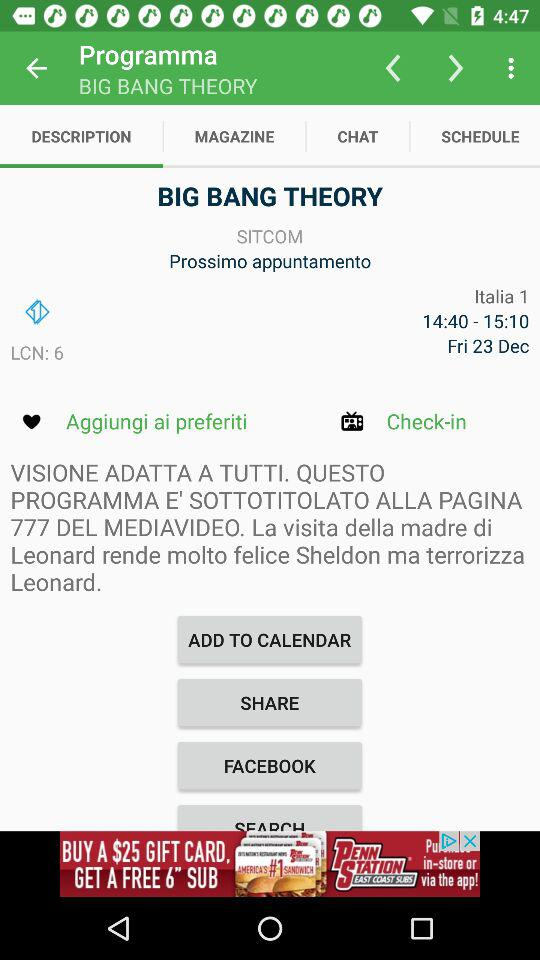What is the LCN number? The LCN number is 6. 